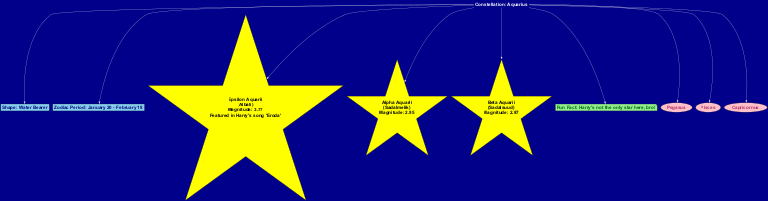What is the name of the constellation? The diagram explicitly states the name of the constellation at the top section as "Aquarius."
Answer: Aquarius What is Epsilon Aquarii's nickname? Epsilon Aquarii is listed in the diagram with the nickname "Albali."
Answer: Albali What is the magnitude of Beta Aquarii? The star Beta Aquarii's magnitude is mentioned in the diagram as "2.87."
Answer: 2.87 What is the zodiac period for Aquarius? The zodiac period is stated in the diagram as "January 20 - February 18."
Answer: January 20 - February 18 How many stars are highlighted in the constellation? The diagram lists three stars under 'starElements', indicating there are three stars highlighted in the constellation.
Answer: 3 What is the fun fact mentioned in the diagram? The specific fun fact about the constellation is found at the bottom stating, "Harry's not the only star here, bro!"
Answer: Harry's not the only star here, bro! Which star features a note about Harry's song? The diagram notes that Epsilon Aquarii is featured in Harry's song "Eroda."
Answer: Epsilon Aquarii What is the shape of the constellation Aquarius? Aquarius is described in the diagram as having the shape of the "Water Bearer."
Answer: Water Bearer Name one constellation nearby Aquarius. The diagram lists nearby constellations, any one of which can serve as an answer; for example, "Pegasus" is mentioned.
Answer: Pegasus 